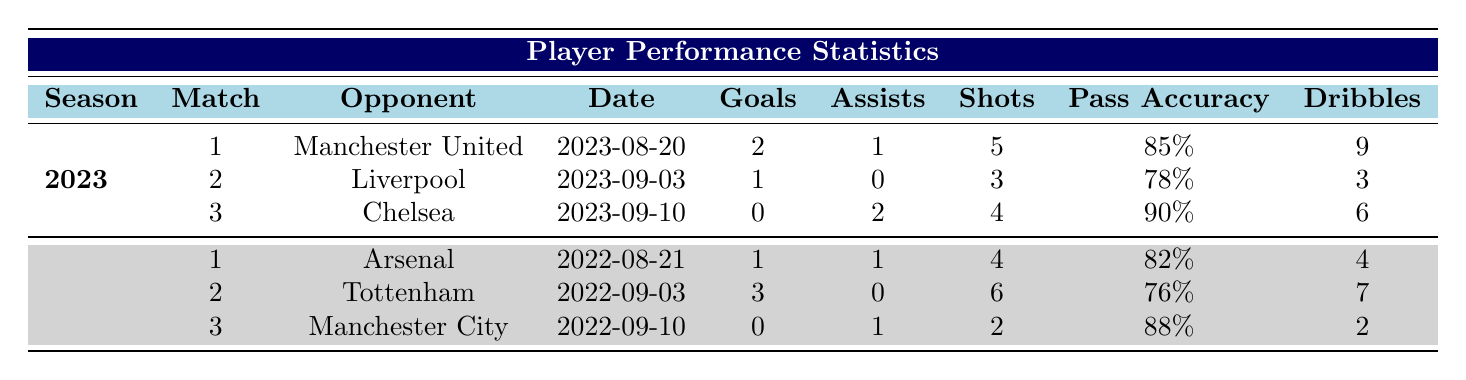What were the total goals scored by the player in the 2023 season? To find the total goals in the 2023 season, I will add the goals from each match: 2 (Match 1) + 1 (Match 2) + 0 (Match 3) = 3.
Answer: 3 How many assists did the player have in the 2022 season? The assists in the 2022 season are 1 (Match 1) + 0 (Match 2) + 1 (Match 3). Adding these gives a total of 2 assists.
Answer: 2 Did the player score any goals against Chelsea in the 2023 season? According to the table, the player scored 0 goals against Chelsea in Match 3, which confirms the answer is no.
Answer: No What is the average pass accuracy of the player across the 2023 season? To find the average pass accuracy in the 2023 season, I will sum the pass accuracies: 85 (Match 1) + 78 (Match 2) + 90 (Match 3) = 253. Then, I divide by 3 matches, resulting in 253/3 = approximately 84.33.
Answer: 84.33 Which match had the highest number of shots in the 2022 season? Looking across the 2022 season, Match 2 against Tottenham had the highest number of shots at 6.
Answer: Match 2 against Tottenham What is the total number of dribbles performed by the player in the 2023 season? To find the total dribbles in the 2023 season, I will add the dribbles from each match: 9 (Match 1) + 3 (Match 2) + 6 (Match 3) = 18.
Answer: 18 How many fouls did the player commit in the 2022 season? Adding the fouls from each match in the 2022 season gives: 3 (Match 1) + 2 (Match 2) + 1 (Match 3) = 6 fouls total.
Answer: 6 In which match did the player achieve the highest pass accuracy in the 2023 season? The highest pass accuracy in the 2023 season was 90% during Match 3 against Chelsea.
Answer: Match 3 against Chelsea Was the total number of goals in the 2022 season less than in the 2023 season? The total goals for 2022 are 1 (Match 1) + 3 (Match 2) + 0 (Match 3) = 4, and for 2023, it is 3. Since 4 is greater than 3, the answer is no.
Answer: No 